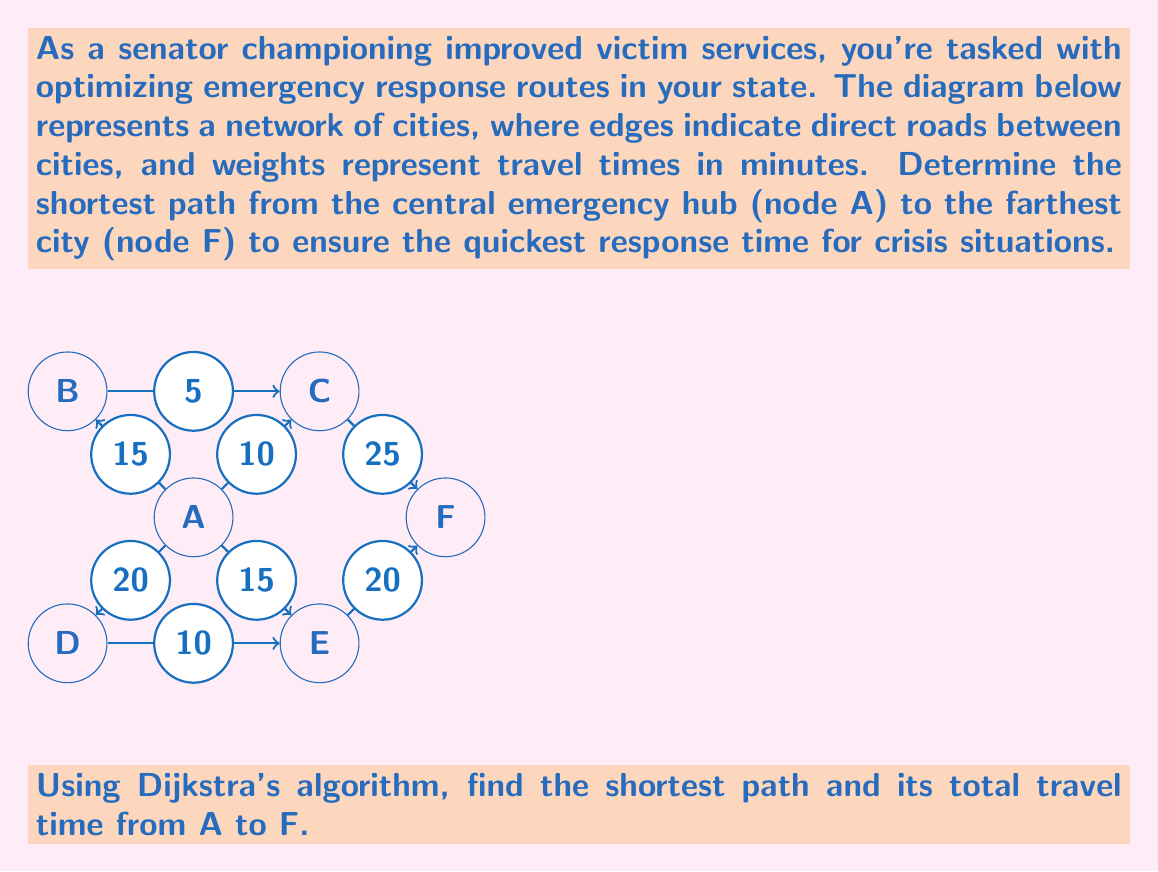Help me with this question. To solve this problem, we'll use Dijkstra's algorithm to find the shortest path from node A to node F. Here's a step-by-step explanation:

1) Initialize:
   - Set distance to A as 0, and all other nodes as infinity.
   - Set all nodes as unvisited.
   - Set A as the current node.

2) For the current node, consider all unvisited neighbors and calculate their tentative distances:
   - Distance to B = 15
   - Distance to C = 10
   - Distance to D = 20
   - Distance to E = 15

3) Mark A as visited. The tentative distances are:
   A(0), B(15), C(10), D(20), E(15), F(∞)

4) Select the unvisited node with the smallest tentative distance (C) as the new current node.

5) From C, update distances:
   - Distance to B = min(15, 10 + 5) = 15 (no change)
   - Distance to F = min(∞, 10 + 25) = 35

6) Mark C as visited. Tentative distances:
   A(0), B(15), C(10), D(20), E(15), F(35)

7) Select E as the new current node (smallest unvisited distance).

8) From E, update distances:
   - Distance to D = min(20, 15 + 10) = 20 (no change)
   - Distance to F = min(35, 15 + 20) = 35 (no change)

9) Mark E as visited. No changes in distances.

10) Select B as the new current node.

11) From B, no updates possible.

12) Mark B as visited. Select D, then F, marking each visited.

The algorithm terminates as F is visited. The shortest path is A → C → F with a total distance of 35 minutes.
Answer: A → C → F, 35 minutes 